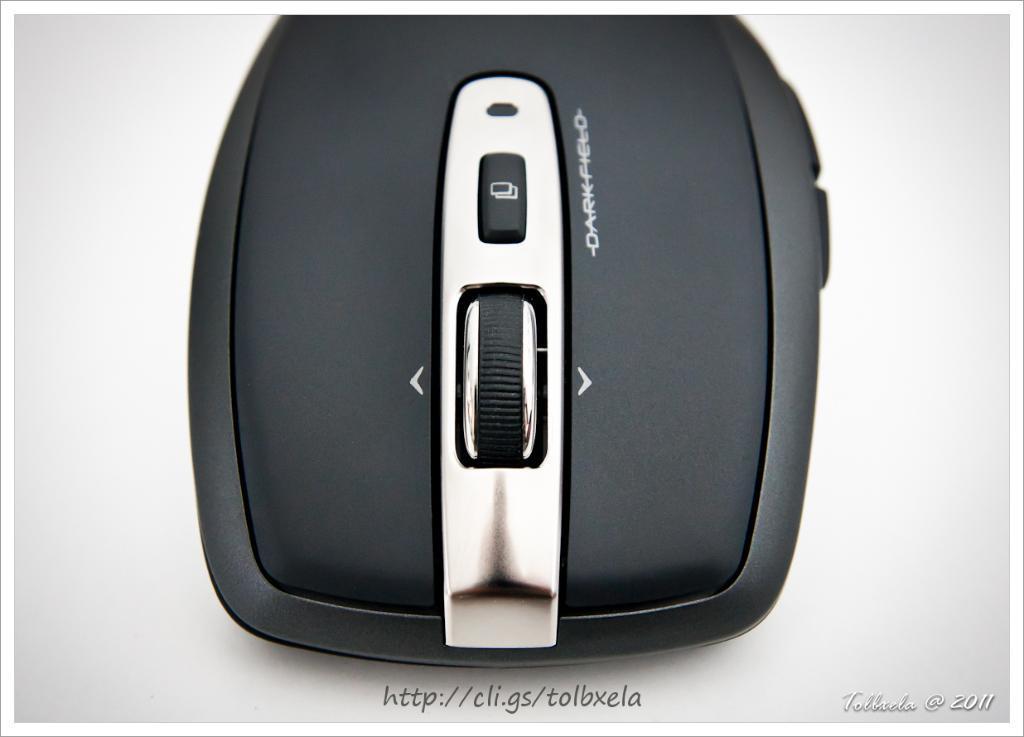Please provide a concise description of this image. This image consists of a mouse with some text written on it. 